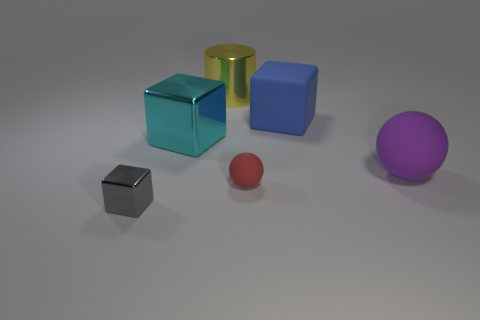Subtract all tiny gray metallic blocks. How many blocks are left? 2 Add 4 red metallic objects. How many objects exist? 10 Subtract 1 cubes. How many cubes are left? 2 Subtract all spheres. How many objects are left? 4 Subtract all green cubes. Subtract all brown cylinders. How many cubes are left? 3 Subtract all large red matte cylinders. Subtract all small rubber spheres. How many objects are left? 5 Add 4 large cyan things. How many large cyan things are left? 5 Add 3 cyan cubes. How many cyan cubes exist? 4 Subtract 0 blue cylinders. How many objects are left? 6 